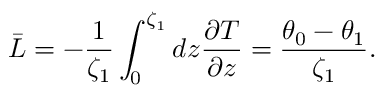Convert formula to latex. <formula><loc_0><loc_0><loc_500><loc_500>\bar { L } = - \frac { 1 } { \zeta _ { 1 } } \int _ { 0 } ^ { \zeta _ { 1 } } d z \frac { \partial T } { \partial z } = \frac { \theta _ { 0 } - \theta _ { 1 } } { \zeta _ { 1 } } .</formula> 